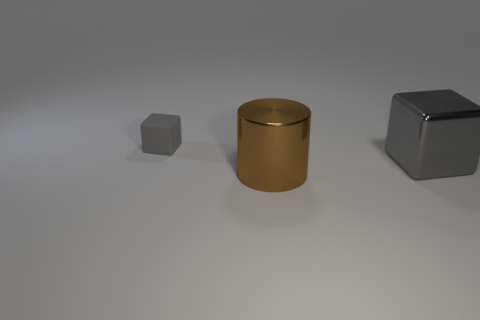Is there any other thing that has the same material as the small block?
Ensure brevity in your answer.  No. Are there any large objects that have the same shape as the small object?
Your answer should be compact. Yes. The shiny thing that is to the left of the big metallic object behind the shiny cylinder is what shape?
Provide a succinct answer. Cylinder. What is the color of the cube that is in front of the tiny rubber block?
Make the answer very short. Gray. The brown object that is made of the same material as the large block is what size?
Your answer should be very brief. Large. What size is the other thing that is the same shape as the small object?
Your answer should be very brief. Large. Is there a yellow cylinder?
Ensure brevity in your answer.  No. How many things are objects that are on the right side of the big brown shiny object or big gray cubes?
Your answer should be compact. 1. There is a cube that is the same size as the brown object; what is it made of?
Your response must be concise. Metal. What is the color of the metal thing that is behind the shiny object in front of the big gray metal thing?
Offer a terse response. Gray. 